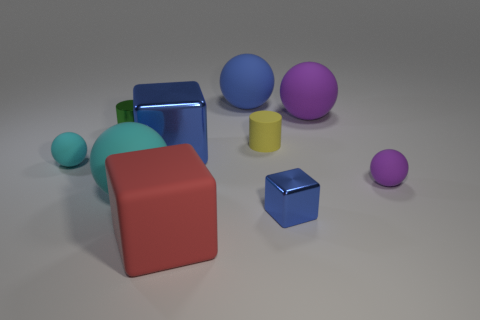Subtract all big blue spheres. How many spheres are left? 4 Subtract 3 spheres. How many spheres are left? 2 Subtract all yellow cylinders. How many purple spheres are left? 2 Subtract all red cubes. How many cubes are left? 2 Subtract all cylinders. How many objects are left? 8 Add 6 tiny cyan matte spheres. How many tiny cyan matte spheres exist? 7 Subtract 0 brown blocks. How many objects are left? 10 Subtract all cyan cubes. Subtract all red cylinders. How many cubes are left? 3 Subtract all red metal balls. Subtract all tiny balls. How many objects are left? 8 Add 2 green metal cylinders. How many green metal cylinders are left? 3 